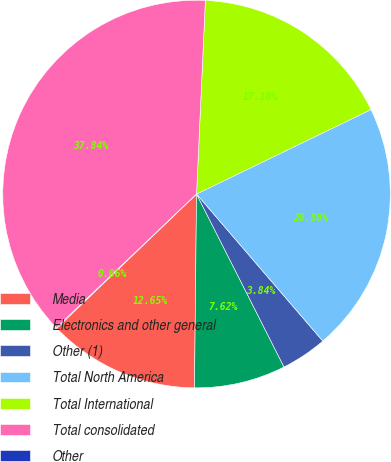Convert chart. <chart><loc_0><loc_0><loc_500><loc_500><pie_chart><fcel>Media<fcel>Electronics and other general<fcel>Other (1)<fcel>Total North America<fcel>Total International<fcel>Total consolidated<fcel>Other<nl><fcel>12.65%<fcel>7.62%<fcel>3.84%<fcel>20.88%<fcel>17.1%<fcel>37.84%<fcel>0.06%<nl></chart> 